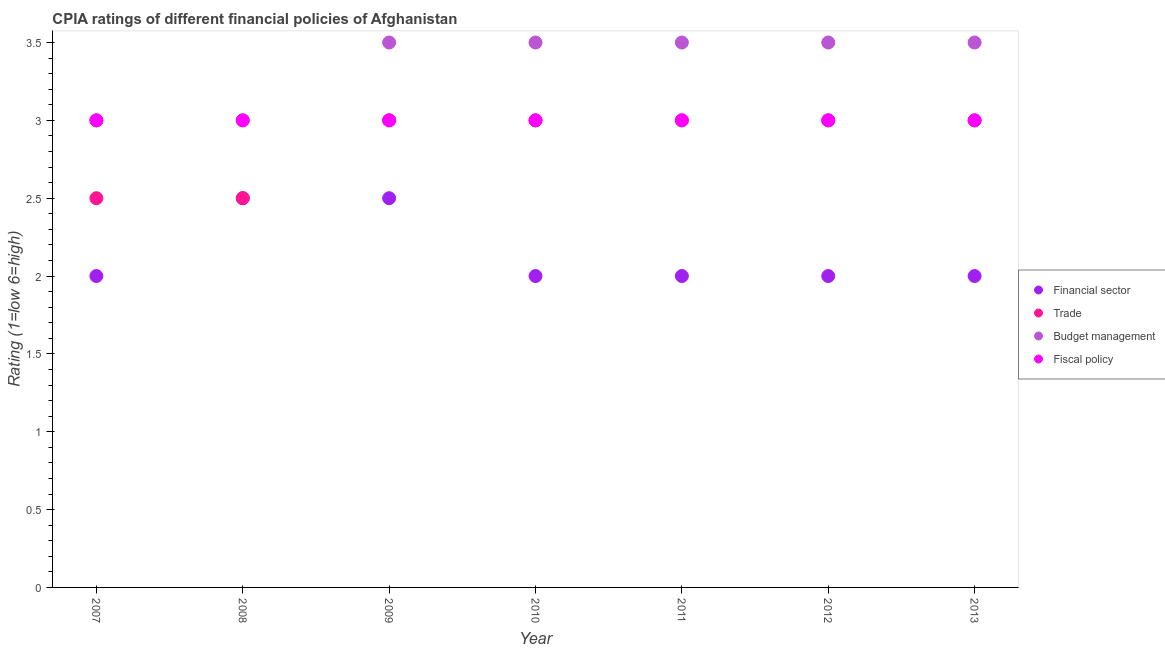How many different coloured dotlines are there?
Make the answer very short. 4. Is the number of dotlines equal to the number of legend labels?
Offer a very short reply. Yes. What is the cpia rating of trade in 2007?
Provide a succinct answer. 2.5. In which year was the cpia rating of trade minimum?
Make the answer very short. 2007. What is the total cpia rating of trade in the graph?
Give a very brief answer. 20. What is the average cpia rating of financial sector per year?
Keep it short and to the point. 2.14. In how many years, is the cpia rating of fiscal policy greater than 1.7?
Provide a short and direct response. 7. What is the ratio of the cpia rating of budget management in 2010 to that in 2011?
Provide a short and direct response. 1. Is the cpia rating of trade in 2007 less than that in 2009?
Provide a short and direct response. Yes. What is the difference between the highest and the second highest cpia rating of trade?
Ensure brevity in your answer.  0. Is it the case that in every year, the sum of the cpia rating of financial sector and cpia rating of trade is greater than the cpia rating of budget management?
Offer a very short reply. Yes. Does the cpia rating of trade monotonically increase over the years?
Provide a succinct answer. No. Is the cpia rating of trade strictly greater than the cpia rating of budget management over the years?
Your answer should be very brief. No. Is the cpia rating of fiscal policy strictly less than the cpia rating of budget management over the years?
Provide a short and direct response. No. How many dotlines are there?
Provide a succinct answer. 4. What is the difference between two consecutive major ticks on the Y-axis?
Your answer should be very brief. 0.5. Does the graph contain grids?
Make the answer very short. No. Where does the legend appear in the graph?
Offer a very short reply. Center right. What is the title of the graph?
Your answer should be very brief. CPIA ratings of different financial policies of Afghanistan. What is the label or title of the X-axis?
Give a very brief answer. Year. What is the label or title of the Y-axis?
Offer a terse response. Rating (1=low 6=high). What is the Rating (1=low 6=high) in Financial sector in 2007?
Your answer should be compact. 2. What is the Rating (1=low 6=high) in Budget management in 2007?
Offer a very short reply. 3. What is the Rating (1=low 6=high) in Fiscal policy in 2007?
Give a very brief answer. 3. What is the Rating (1=low 6=high) of Trade in 2008?
Ensure brevity in your answer.  2.5. What is the Rating (1=low 6=high) in Financial sector in 2009?
Give a very brief answer. 2.5. What is the Rating (1=low 6=high) in Budget management in 2009?
Your answer should be compact. 3.5. What is the Rating (1=low 6=high) of Fiscal policy in 2009?
Your answer should be compact. 3. What is the Rating (1=low 6=high) of Financial sector in 2010?
Keep it short and to the point. 2. What is the Rating (1=low 6=high) of Trade in 2010?
Offer a very short reply. 3. What is the Rating (1=low 6=high) in Fiscal policy in 2010?
Your answer should be very brief. 3. What is the Rating (1=low 6=high) of Financial sector in 2011?
Ensure brevity in your answer.  2. What is the Rating (1=low 6=high) of Budget management in 2011?
Make the answer very short. 3.5. What is the Rating (1=low 6=high) of Trade in 2012?
Give a very brief answer. 3. What is the Rating (1=low 6=high) of Budget management in 2012?
Ensure brevity in your answer.  3.5. What is the Rating (1=low 6=high) in Fiscal policy in 2012?
Make the answer very short. 3. What is the Rating (1=low 6=high) of Trade in 2013?
Provide a succinct answer. 3. Across all years, what is the maximum Rating (1=low 6=high) in Financial sector?
Make the answer very short. 2.5. Across all years, what is the minimum Rating (1=low 6=high) of Trade?
Provide a short and direct response. 2.5. Across all years, what is the minimum Rating (1=low 6=high) of Fiscal policy?
Make the answer very short. 3. What is the total Rating (1=low 6=high) in Financial sector in the graph?
Provide a short and direct response. 15. What is the total Rating (1=low 6=high) of Trade in the graph?
Offer a terse response. 20. What is the total Rating (1=low 6=high) in Fiscal policy in the graph?
Offer a very short reply. 21. What is the difference between the Rating (1=low 6=high) in Trade in 2007 and that in 2008?
Give a very brief answer. 0. What is the difference between the Rating (1=low 6=high) of Budget management in 2007 and that in 2008?
Ensure brevity in your answer.  0. What is the difference between the Rating (1=low 6=high) of Financial sector in 2007 and that in 2009?
Give a very brief answer. -0.5. What is the difference between the Rating (1=low 6=high) of Budget management in 2007 and that in 2009?
Offer a very short reply. -0.5. What is the difference between the Rating (1=low 6=high) of Fiscal policy in 2007 and that in 2009?
Make the answer very short. 0. What is the difference between the Rating (1=low 6=high) of Budget management in 2007 and that in 2010?
Provide a short and direct response. -0.5. What is the difference between the Rating (1=low 6=high) of Fiscal policy in 2007 and that in 2010?
Your response must be concise. 0. What is the difference between the Rating (1=low 6=high) in Budget management in 2007 and that in 2011?
Provide a short and direct response. -0.5. What is the difference between the Rating (1=low 6=high) of Fiscal policy in 2007 and that in 2011?
Ensure brevity in your answer.  0. What is the difference between the Rating (1=low 6=high) of Budget management in 2007 and that in 2012?
Keep it short and to the point. -0.5. What is the difference between the Rating (1=low 6=high) of Financial sector in 2007 and that in 2013?
Provide a succinct answer. 0. What is the difference between the Rating (1=low 6=high) of Trade in 2007 and that in 2013?
Make the answer very short. -0.5. What is the difference between the Rating (1=low 6=high) in Budget management in 2007 and that in 2013?
Ensure brevity in your answer.  -0.5. What is the difference between the Rating (1=low 6=high) of Fiscal policy in 2007 and that in 2013?
Your answer should be very brief. 0. What is the difference between the Rating (1=low 6=high) in Financial sector in 2008 and that in 2009?
Keep it short and to the point. 0. What is the difference between the Rating (1=low 6=high) in Fiscal policy in 2008 and that in 2010?
Provide a succinct answer. 0. What is the difference between the Rating (1=low 6=high) of Trade in 2008 and that in 2011?
Ensure brevity in your answer.  -0.5. What is the difference between the Rating (1=low 6=high) of Trade in 2008 and that in 2013?
Your answer should be very brief. -0.5. What is the difference between the Rating (1=low 6=high) in Budget management in 2008 and that in 2013?
Your answer should be very brief. -0.5. What is the difference between the Rating (1=low 6=high) in Fiscal policy in 2008 and that in 2013?
Make the answer very short. 0. What is the difference between the Rating (1=low 6=high) in Financial sector in 2009 and that in 2010?
Provide a succinct answer. 0.5. What is the difference between the Rating (1=low 6=high) in Fiscal policy in 2009 and that in 2010?
Provide a short and direct response. 0. What is the difference between the Rating (1=low 6=high) in Financial sector in 2009 and that in 2011?
Provide a succinct answer. 0.5. What is the difference between the Rating (1=low 6=high) of Trade in 2009 and that in 2011?
Your response must be concise. 0. What is the difference between the Rating (1=low 6=high) in Financial sector in 2009 and that in 2012?
Make the answer very short. 0.5. What is the difference between the Rating (1=low 6=high) of Financial sector in 2009 and that in 2013?
Ensure brevity in your answer.  0.5. What is the difference between the Rating (1=low 6=high) of Trade in 2009 and that in 2013?
Offer a terse response. 0. What is the difference between the Rating (1=low 6=high) in Budget management in 2009 and that in 2013?
Offer a terse response. 0. What is the difference between the Rating (1=low 6=high) in Fiscal policy in 2009 and that in 2013?
Provide a succinct answer. 0. What is the difference between the Rating (1=low 6=high) in Financial sector in 2010 and that in 2011?
Give a very brief answer. 0. What is the difference between the Rating (1=low 6=high) in Trade in 2010 and that in 2012?
Provide a succinct answer. 0. What is the difference between the Rating (1=low 6=high) in Financial sector in 2010 and that in 2013?
Your answer should be compact. 0. What is the difference between the Rating (1=low 6=high) in Budget management in 2010 and that in 2013?
Provide a succinct answer. 0. What is the difference between the Rating (1=low 6=high) of Trade in 2011 and that in 2012?
Your answer should be compact. 0. What is the difference between the Rating (1=low 6=high) in Trade in 2011 and that in 2013?
Give a very brief answer. 0. What is the difference between the Rating (1=low 6=high) of Fiscal policy in 2011 and that in 2013?
Give a very brief answer. 0. What is the difference between the Rating (1=low 6=high) of Financial sector in 2012 and that in 2013?
Your answer should be very brief. 0. What is the difference between the Rating (1=low 6=high) of Trade in 2012 and that in 2013?
Your answer should be very brief. 0. What is the difference between the Rating (1=low 6=high) of Budget management in 2012 and that in 2013?
Ensure brevity in your answer.  0. What is the difference between the Rating (1=low 6=high) of Fiscal policy in 2012 and that in 2013?
Keep it short and to the point. 0. What is the difference between the Rating (1=low 6=high) of Financial sector in 2007 and the Rating (1=low 6=high) of Trade in 2008?
Ensure brevity in your answer.  -0.5. What is the difference between the Rating (1=low 6=high) of Financial sector in 2007 and the Rating (1=low 6=high) of Budget management in 2008?
Provide a succinct answer. -1. What is the difference between the Rating (1=low 6=high) of Trade in 2007 and the Rating (1=low 6=high) of Budget management in 2008?
Your response must be concise. -0.5. What is the difference between the Rating (1=low 6=high) of Budget management in 2007 and the Rating (1=low 6=high) of Fiscal policy in 2008?
Give a very brief answer. 0. What is the difference between the Rating (1=low 6=high) of Financial sector in 2007 and the Rating (1=low 6=high) of Trade in 2009?
Ensure brevity in your answer.  -1. What is the difference between the Rating (1=low 6=high) of Financial sector in 2007 and the Rating (1=low 6=high) of Budget management in 2009?
Ensure brevity in your answer.  -1.5. What is the difference between the Rating (1=low 6=high) in Financial sector in 2007 and the Rating (1=low 6=high) in Fiscal policy in 2009?
Ensure brevity in your answer.  -1. What is the difference between the Rating (1=low 6=high) in Trade in 2007 and the Rating (1=low 6=high) in Budget management in 2009?
Provide a succinct answer. -1. What is the difference between the Rating (1=low 6=high) of Trade in 2007 and the Rating (1=low 6=high) of Fiscal policy in 2009?
Offer a very short reply. -0.5. What is the difference between the Rating (1=low 6=high) in Budget management in 2007 and the Rating (1=low 6=high) in Fiscal policy in 2009?
Offer a very short reply. 0. What is the difference between the Rating (1=low 6=high) of Financial sector in 2007 and the Rating (1=low 6=high) of Trade in 2010?
Keep it short and to the point. -1. What is the difference between the Rating (1=low 6=high) in Financial sector in 2007 and the Rating (1=low 6=high) in Budget management in 2010?
Provide a short and direct response. -1.5. What is the difference between the Rating (1=low 6=high) of Financial sector in 2007 and the Rating (1=low 6=high) of Fiscal policy in 2010?
Your response must be concise. -1. What is the difference between the Rating (1=low 6=high) of Trade in 2007 and the Rating (1=low 6=high) of Budget management in 2010?
Your answer should be very brief. -1. What is the difference between the Rating (1=low 6=high) of Trade in 2007 and the Rating (1=low 6=high) of Fiscal policy in 2010?
Give a very brief answer. -0.5. What is the difference between the Rating (1=low 6=high) in Trade in 2007 and the Rating (1=low 6=high) in Budget management in 2011?
Your answer should be very brief. -1. What is the difference between the Rating (1=low 6=high) in Budget management in 2007 and the Rating (1=low 6=high) in Fiscal policy in 2011?
Keep it short and to the point. 0. What is the difference between the Rating (1=low 6=high) in Financial sector in 2007 and the Rating (1=low 6=high) in Trade in 2012?
Make the answer very short. -1. What is the difference between the Rating (1=low 6=high) in Trade in 2007 and the Rating (1=low 6=high) in Budget management in 2012?
Keep it short and to the point. -1. What is the difference between the Rating (1=low 6=high) in Financial sector in 2007 and the Rating (1=low 6=high) in Budget management in 2013?
Make the answer very short. -1.5. What is the difference between the Rating (1=low 6=high) in Financial sector in 2007 and the Rating (1=low 6=high) in Fiscal policy in 2013?
Make the answer very short. -1. What is the difference between the Rating (1=low 6=high) of Trade in 2007 and the Rating (1=low 6=high) of Budget management in 2013?
Give a very brief answer. -1. What is the difference between the Rating (1=low 6=high) in Trade in 2007 and the Rating (1=low 6=high) in Fiscal policy in 2013?
Your answer should be compact. -0.5. What is the difference between the Rating (1=low 6=high) of Financial sector in 2008 and the Rating (1=low 6=high) of Trade in 2009?
Your answer should be compact. -0.5. What is the difference between the Rating (1=low 6=high) in Financial sector in 2008 and the Rating (1=low 6=high) in Budget management in 2009?
Offer a very short reply. -1. What is the difference between the Rating (1=low 6=high) in Financial sector in 2008 and the Rating (1=low 6=high) in Fiscal policy in 2009?
Your answer should be very brief. -0.5. What is the difference between the Rating (1=low 6=high) in Trade in 2008 and the Rating (1=low 6=high) in Fiscal policy in 2009?
Your answer should be very brief. -0.5. What is the difference between the Rating (1=low 6=high) of Budget management in 2008 and the Rating (1=low 6=high) of Fiscal policy in 2009?
Offer a terse response. 0. What is the difference between the Rating (1=low 6=high) in Financial sector in 2008 and the Rating (1=low 6=high) in Budget management in 2010?
Your response must be concise. -1. What is the difference between the Rating (1=low 6=high) of Trade in 2008 and the Rating (1=low 6=high) of Budget management in 2010?
Provide a succinct answer. -1. What is the difference between the Rating (1=low 6=high) in Financial sector in 2008 and the Rating (1=low 6=high) in Trade in 2011?
Offer a very short reply. -0.5. What is the difference between the Rating (1=low 6=high) in Financial sector in 2008 and the Rating (1=low 6=high) in Budget management in 2011?
Provide a succinct answer. -1. What is the difference between the Rating (1=low 6=high) of Trade in 2008 and the Rating (1=low 6=high) of Budget management in 2011?
Make the answer very short. -1. What is the difference between the Rating (1=low 6=high) of Budget management in 2008 and the Rating (1=low 6=high) of Fiscal policy in 2011?
Make the answer very short. 0. What is the difference between the Rating (1=low 6=high) in Financial sector in 2008 and the Rating (1=low 6=high) in Fiscal policy in 2012?
Offer a very short reply. -0.5. What is the difference between the Rating (1=low 6=high) in Financial sector in 2008 and the Rating (1=low 6=high) in Budget management in 2013?
Provide a succinct answer. -1. What is the difference between the Rating (1=low 6=high) of Trade in 2008 and the Rating (1=low 6=high) of Fiscal policy in 2013?
Give a very brief answer. -0.5. What is the difference between the Rating (1=low 6=high) in Financial sector in 2009 and the Rating (1=low 6=high) in Trade in 2010?
Your response must be concise. -0.5. What is the difference between the Rating (1=low 6=high) of Trade in 2009 and the Rating (1=low 6=high) of Budget management in 2010?
Offer a terse response. -0.5. What is the difference between the Rating (1=low 6=high) in Budget management in 2009 and the Rating (1=low 6=high) in Fiscal policy in 2010?
Keep it short and to the point. 0.5. What is the difference between the Rating (1=low 6=high) in Financial sector in 2009 and the Rating (1=low 6=high) in Trade in 2012?
Provide a short and direct response. -0.5. What is the difference between the Rating (1=low 6=high) of Financial sector in 2009 and the Rating (1=low 6=high) of Budget management in 2012?
Your answer should be very brief. -1. What is the difference between the Rating (1=low 6=high) in Trade in 2009 and the Rating (1=low 6=high) in Budget management in 2012?
Your response must be concise. -0.5. What is the difference between the Rating (1=low 6=high) in Budget management in 2009 and the Rating (1=low 6=high) in Fiscal policy in 2012?
Give a very brief answer. 0.5. What is the difference between the Rating (1=low 6=high) of Financial sector in 2009 and the Rating (1=low 6=high) of Trade in 2013?
Your response must be concise. -0.5. What is the difference between the Rating (1=low 6=high) in Financial sector in 2009 and the Rating (1=low 6=high) in Budget management in 2013?
Your response must be concise. -1. What is the difference between the Rating (1=low 6=high) in Trade in 2009 and the Rating (1=low 6=high) in Budget management in 2013?
Offer a very short reply. -0.5. What is the difference between the Rating (1=low 6=high) of Trade in 2009 and the Rating (1=low 6=high) of Fiscal policy in 2013?
Your response must be concise. 0. What is the difference between the Rating (1=low 6=high) in Budget management in 2010 and the Rating (1=low 6=high) in Fiscal policy in 2011?
Make the answer very short. 0.5. What is the difference between the Rating (1=low 6=high) of Financial sector in 2010 and the Rating (1=low 6=high) of Budget management in 2012?
Keep it short and to the point. -1.5. What is the difference between the Rating (1=low 6=high) in Financial sector in 2010 and the Rating (1=low 6=high) in Fiscal policy in 2012?
Your answer should be very brief. -1. What is the difference between the Rating (1=low 6=high) in Financial sector in 2010 and the Rating (1=low 6=high) in Trade in 2013?
Provide a short and direct response. -1. What is the difference between the Rating (1=low 6=high) of Trade in 2010 and the Rating (1=low 6=high) of Budget management in 2013?
Your answer should be very brief. -0.5. What is the difference between the Rating (1=low 6=high) of Trade in 2010 and the Rating (1=low 6=high) of Fiscal policy in 2013?
Your response must be concise. 0. What is the difference between the Rating (1=low 6=high) in Financial sector in 2011 and the Rating (1=low 6=high) in Trade in 2012?
Offer a very short reply. -1. What is the difference between the Rating (1=low 6=high) in Financial sector in 2011 and the Rating (1=low 6=high) in Budget management in 2012?
Provide a short and direct response. -1.5. What is the difference between the Rating (1=low 6=high) of Trade in 2011 and the Rating (1=low 6=high) of Budget management in 2012?
Offer a very short reply. -0.5. What is the difference between the Rating (1=low 6=high) of Trade in 2011 and the Rating (1=low 6=high) of Fiscal policy in 2012?
Provide a succinct answer. 0. What is the difference between the Rating (1=low 6=high) of Budget management in 2011 and the Rating (1=low 6=high) of Fiscal policy in 2012?
Your answer should be very brief. 0.5. What is the difference between the Rating (1=low 6=high) of Financial sector in 2011 and the Rating (1=low 6=high) of Fiscal policy in 2013?
Offer a very short reply. -1. What is the difference between the Rating (1=low 6=high) in Trade in 2011 and the Rating (1=low 6=high) in Fiscal policy in 2013?
Keep it short and to the point. 0. What is the difference between the Rating (1=low 6=high) of Budget management in 2011 and the Rating (1=low 6=high) of Fiscal policy in 2013?
Your answer should be compact. 0.5. What is the difference between the Rating (1=low 6=high) in Trade in 2012 and the Rating (1=low 6=high) in Budget management in 2013?
Your answer should be compact. -0.5. What is the difference between the Rating (1=low 6=high) in Budget management in 2012 and the Rating (1=low 6=high) in Fiscal policy in 2013?
Offer a very short reply. 0.5. What is the average Rating (1=low 6=high) of Financial sector per year?
Offer a terse response. 2.14. What is the average Rating (1=low 6=high) in Trade per year?
Provide a succinct answer. 2.86. What is the average Rating (1=low 6=high) of Budget management per year?
Offer a terse response. 3.36. What is the average Rating (1=low 6=high) of Fiscal policy per year?
Your response must be concise. 3. In the year 2007, what is the difference between the Rating (1=low 6=high) of Financial sector and Rating (1=low 6=high) of Trade?
Offer a very short reply. -0.5. In the year 2007, what is the difference between the Rating (1=low 6=high) of Financial sector and Rating (1=low 6=high) of Budget management?
Your answer should be very brief. -1. In the year 2007, what is the difference between the Rating (1=low 6=high) in Financial sector and Rating (1=low 6=high) in Fiscal policy?
Provide a succinct answer. -1. In the year 2007, what is the difference between the Rating (1=low 6=high) of Trade and Rating (1=low 6=high) of Budget management?
Offer a terse response. -0.5. In the year 2007, what is the difference between the Rating (1=low 6=high) of Trade and Rating (1=low 6=high) of Fiscal policy?
Keep it short and to the point. -0.5. In the year 2008, what is the difference between the Rating (1=low 6=high) of Trade and Rating (1=low 6=high) of Budget management?
Ensure brevity in your answer.  -0.5. In the year 2008, what is the difference between the Rating (1=low 6=high) of Trade and Rating (1=low 6=high) of Fiscal policy?
Provide a succinct answer. -0.5. In the year 2009, what is the difference between the Rating (1=low 6=high) in Trade and Rating (1=low 6=high) in Budget management?
Provide a short and direct response. -0.5. In the year 2009, what is the difference between the Rating (1=low 6=high) of Budget management and Rating (1=low 6=high) of Fiscal policy?
Ensure brevity in your answer.  0.5. In the year 2010, what is the difference between the Rating (1=low 6=high) of Financial sector and Rating (1=low 6=high) of Fiscal policy?
Offer a very short reply. -1. In the year 2010, what is the difference between the Rating (1=low 6=high) of Budget management and Rating (1=low 6=high) of Fiscal policy?
Provide a short and direct response. 0.5. In the year 2011, what is the difference between the Rating (1=low 6=high) in Financial sector and Rating (1=low 6=high) in Trade?
Provide a succinct answer. -1. In the year 2012, what is the difference between the Rating (1=low 6=high) of Financial sector and Rating (1=low 6=high) of Trade?
Offer a very short reply. -1. In the year 2012, what is the difference between the Rating (1=low 6=high) in Financial sector and Rating (1=low 6=high) in Budget management?
Offer a terse response. -1.5. In the year 2012, what is the difference between the Rating (1=low 6=high) in Trade and Rating (1=low 6=high) in Fiscal policy?
Offer a very short reply. 0. In the year 2012, what is the difference between the Rating (1=low 6=high) in Budget management and Rating (1=low 6=high) in Fiscal policy?
Provide a short and direct response. 0.5. In the year 2013, what is the difference between the Rating (1=low 6=high) of Financial sector and Rating (1=low 6=high) of Trade?
Provide a short and direct response. -1. In the year 2013, what is the difference between the Rating (1=low 6=high) of Financial sector and Rating (1=low 6=high) of Budget management?
Give a very brief answer. -1.5. In the year 2013, what is the difference between the Rating (1=low 6=high) of Financial sector and Rating (1=low 6=high) of Fiscal policy?
Ensure brevity in your answer.  -1. In the year 2013, what is the difference between the Rating (1=low 6=high) of Trade and Rating (1=low 6=high) of Fiscal policy?
Your answer should be very brief. 0. In the year 2013, what is the difference between the Rating (1=low 6=high) of Budget management and Rating (1=low 6=high) of Fiscal policy?
Your response must be concise. 0.5. What is the ratio of the Rating (1=low 6=high) in Trade in 2007 to that in 2009?
Provide a short and direct response. 0.83. What is the ratio of the Rating (1=low 6=high) in Budget management in 2007 to that in 2009?
Your answer should be compact. 0.86. What is the ratio of the Rating (1=low 6=high) of Financial sector in 2007 to that in 2010?
Your answer should be very brief. 1. What is the ratio of the Rating (1=low 6=high) of Budget management in 2007 to that in 2010?
Give a very brief answer. 0.86. What is the ratio of the Rating (1=low 6=high) in Fiscal policy in 2007 to that in 2010?
Your answer should be very brief. 1. What is the ratio of the Rating (1=low 6=high) in Financial sector in 2007 to that in 2011?
Provide a short and direct response. 1. What is the ratio of the Rating (1=low 6=high) in Trade in 2007 to that in 2011?
Give a very brief answer. 0.83. What is the ratio of the Rating (1=low 6=high) of Trade in 2007 to that in 2012?
Offer a terse response. 0.83. What is the ratio of the Rating (1=low 6=high) in Budget management in 2007 to that in 2012?
Your answer should be very brief. 0.86. What is the ratio of the Rating (1=low 6=high) in Fiscal policy in 2007 to that in 2012?
Offer a very short reply. 1. What is the ratio of the Rating (1=low 6=high) of Financial sector in 2007 to that in 2013?
Provide a short and direct response. 1. What is the ratio of the Rating (1=low 6=high) in Trade in 2007 to that in 2013?
Provide a short and direct response. 0.83. What is the ratio of the Rating (1=low 6=high) in Trade in 2008 to that in 2009?
Make the answer very short. 0.83. What is the ratio of the Rating (1=low 6=high) in Budget management in 2008 to that in 2009?
Your answer should be very brief. 0.86. What is the ratio of the Rating (1=low 6=high) of Fiscal policy in 2008 to that in 2009?
Offer a very short reply. 1. What is the ratio of the Rating (1=low 6=high) in Trade in 2008 to that in 2010?
Provide a succinct answer. 0.83. What is the ratio of the Rating (1=low 6=high) in Budget management in 2008 to that in 2011?
Give a very brief answer. 0.86. What is the ratio of the Rating (1=low 6=high) in Trade in 2008 to that in 2012?
Provide a short and direct response. 0.83. What is the ratio of the Rating (1=low 6=high) in Fiscal policy in 2008 to that in 2012?
Your answer should be compact. 1. What is the ratio of the Rating (1=low 6=high) in Budget management in 2008 to that in 2013?
Make the answer very short. 0.86. What is the ratio of the Rating (1=low 6=high) in Financial sector in 2009 to that in 2010?
Your answer should be very brief. 1.25. What is the ratio of the Rating (1=low 6=high) of Budget management in 2009 to that in 2010?
Offer a terse response. 1. What is the ratio of the Rating (1=low 6=high) in Budget management in 2009 to that in 2011?
Keep it short and to the point. 1. What is the ratio of the Rating (1=low 6=high) of Trade in 2009 to that in 2012?
Ensure brevity in your answer.  1. What is the ratio of the Rating (1=low 6=high) in Budget management in 2009 to that in 2012?
Make the answer very short. 1. What is the ratio of the Rating (1=low 6=high) of Trade in 2009 to that in 2013?
Keep it short and to the point. 1. What is the ratio of the Rating (1=low 6=high) in Fiscal policy in 2009 to that in 2013?
Keep it short and to the point. 1. What is the ratio of the Rating (1=low 6=high) in Budget management in 2010 to that in 2011?
Provide a succinct answer. 1. What is the ratio of the Rating (1=low 6=high) of Fiscal policy in 2010 to that in 2011?
Provide a succinct answer. 1. What is the ratio of the Rating (1=low 6=high) in Budget management in 2010 to that in 2012?
Your answer should be compact. 1. What is the ratio of the Rating (1=low 6=high) of Financial sector in 2010 to that in 2013?
Offer a terse response. 1. What is the ratio of the Rating (1=low 6=high) in Trade in 2010 to that in 2013?
Make the answer very short. 1. What is the ratio of the Rating (1=low 6=high) of Budget management in 2010 to that in 2013?
Provide a short and direct response. 1. What is the ratio of the Rating (1=low 6=high) of Fiscal policy in 2010 to that in 2013?
Your response must be concise. 1. What is the ratio of the Rating (1=low 6=high) in Financial sector in 2011 to that in 2012?
Provide a short and direct response. 1. What is the ratio of the Rating (1=low 6=high) in Budget management in 2011 to that in 2012?
Your answer should be compact. 1. What is the ratio of the Rating (1=low 6=high) of Financial sector in 2011 to that in 2013?
Offer a very short reply. 1. What is the ratio of the Rating (1=low 6=high) in Trade in 2011 to that in 2013?
Provide a succinct answer. 1. What is the ratio of the Rating (1=low 6=high) of Budget management in 2011 to that in 2013?
Give a very brief answer. 1. What is the ratio of the Rating (1=low 6=high) of Fiscal policy in 2011 to that in 2013?
Provide a succinct answer. 1. What is the ratio of the Rating (1=low 6=high) of Financial sector in 2012 to that in 2013?
Make the answer very short. 1. What is the ratio of the Rating (1=low 6=high) of Trade in 2012 to that in 2013?
Provide a short and direct response. 1. What is the ratio of the Rating (1=low 6=high) of Fiscal policy in 2012 to that in 2013?
Give a very brief answer. 1. What is the difference between the highest and the second highest Rating (1=low 6=high) in Financial sector?
Provide a short and direct response. 0. What is the difference between the highest and the second highest Rating (1=low 6=high) of Trade?
Provide a succinct answer. 0. What is the difference between the highest and the second highest Rating (1=low 6=high) of Fiscal policy?
Provide a short and direct response. 0. What is the difference between the highest and the lowest Rating (1=low 6=high) in Financial sector?
Make the answer very short. 0.5. 